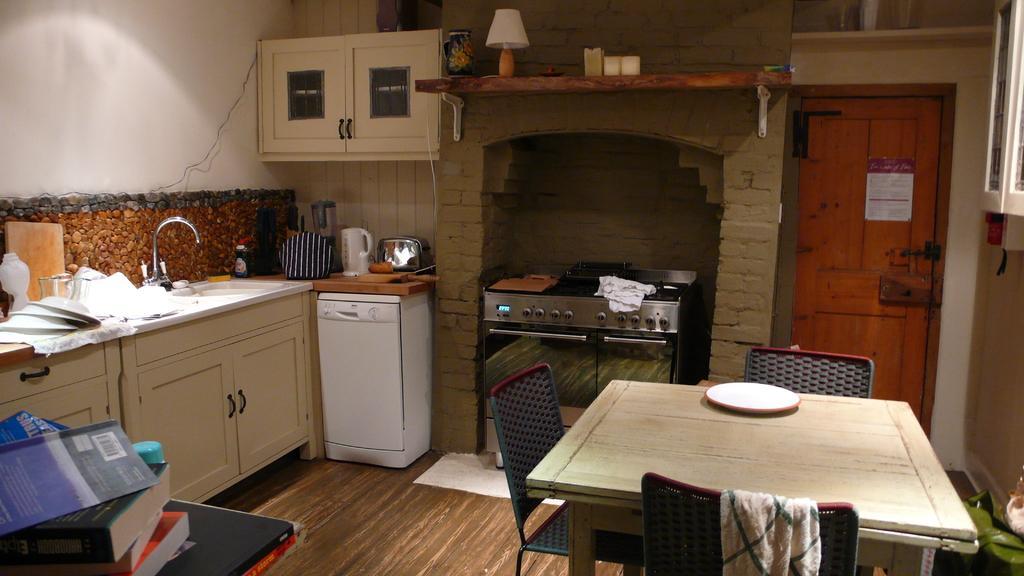In one or two sentences, can you explain what this image depicts? In this image I can see the floor, a table, few chairs around the table, a plate, few books, the counter top, a sink, a tap, few objects on the counter top, the wall, few cabinets, a dishwasher, a gas stove, a lamp and the brown colored door. 